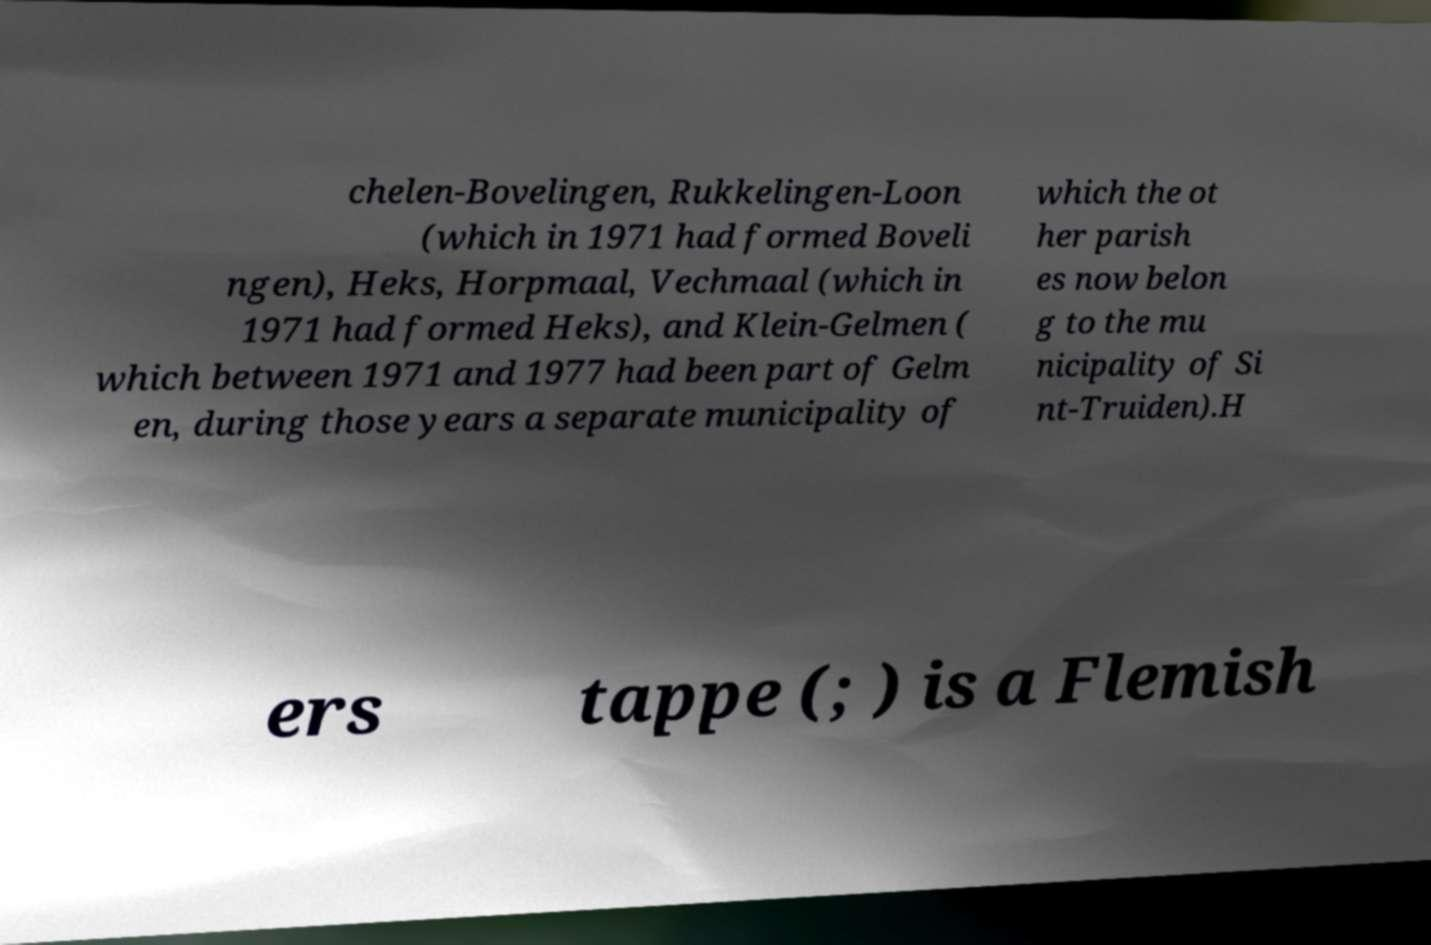There's text embedded in this image that I need extracted. Can you transcribe it verbatim? chelen-Bovelingen, Rukkelingen-Loon (which in 1971 had formed Boveli ngen), Heks, Horpmaal, Vechmaal (which in 1971 had formed Heks), and Klein-Gelmen ( which between 1971 and 1977 had been part of Gelm en, during those years a separate municipality of which the ot her parish es now belon g to the mu nicipality of Si nt-Truiden).H ers tappe (; ) is a Flemish 